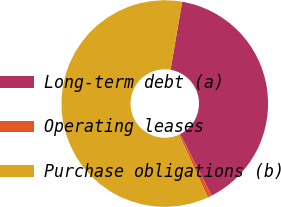Convert chart to OTSL. <chart><loc_0><loc_0><loc_500><loc_500><pie_chart><fcel>Long-term debt (a)<fcel>Operating leases<fcel>Purchase obligations (b)<nl><fcel>39.83%<fcel>0.65%<fcel>59.52%<nl></chart> 